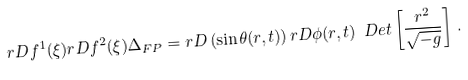Convert formula to latex. <formula><loc_0><loc_0><loc_500><loc_500>r D f ^ { 1 } ( \xi ) r D f ^ { 2 } ( \xi ) \Delta _ { F P } = r D \left ( \sin \theta ( r , t ) \right ) r D \phi ( r , t ) \ D e t \left [ \frac { r ^ { 2 } } { \sqrt { - g } } \right ] \, .</formula> 